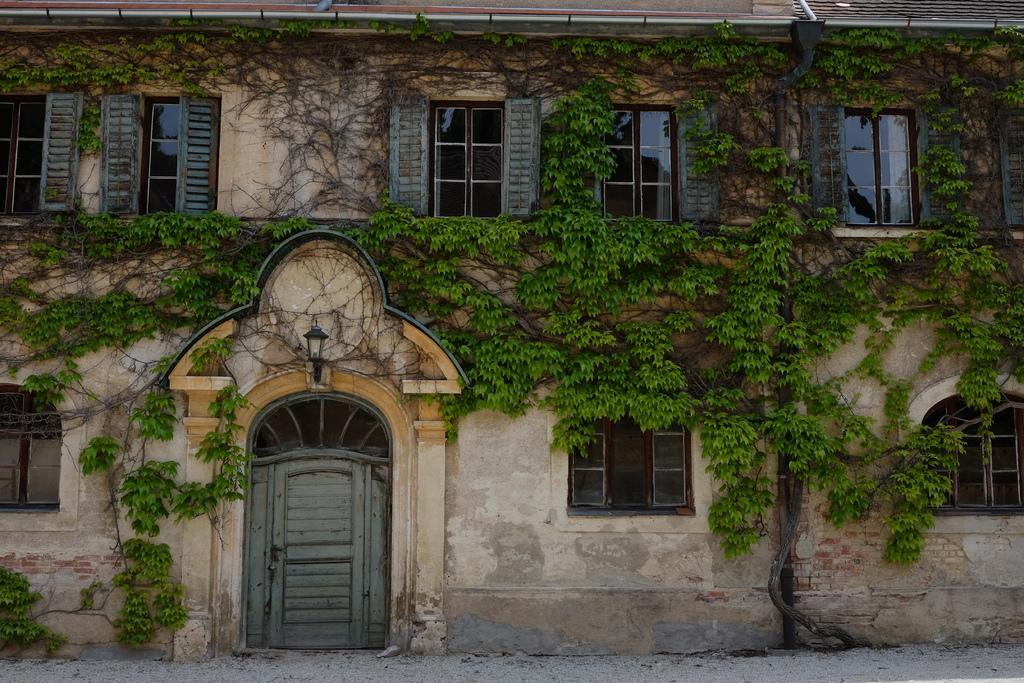Can you describe this image briefly? This is the picture of a house to which there are some windows, door, lamp and some poles. 